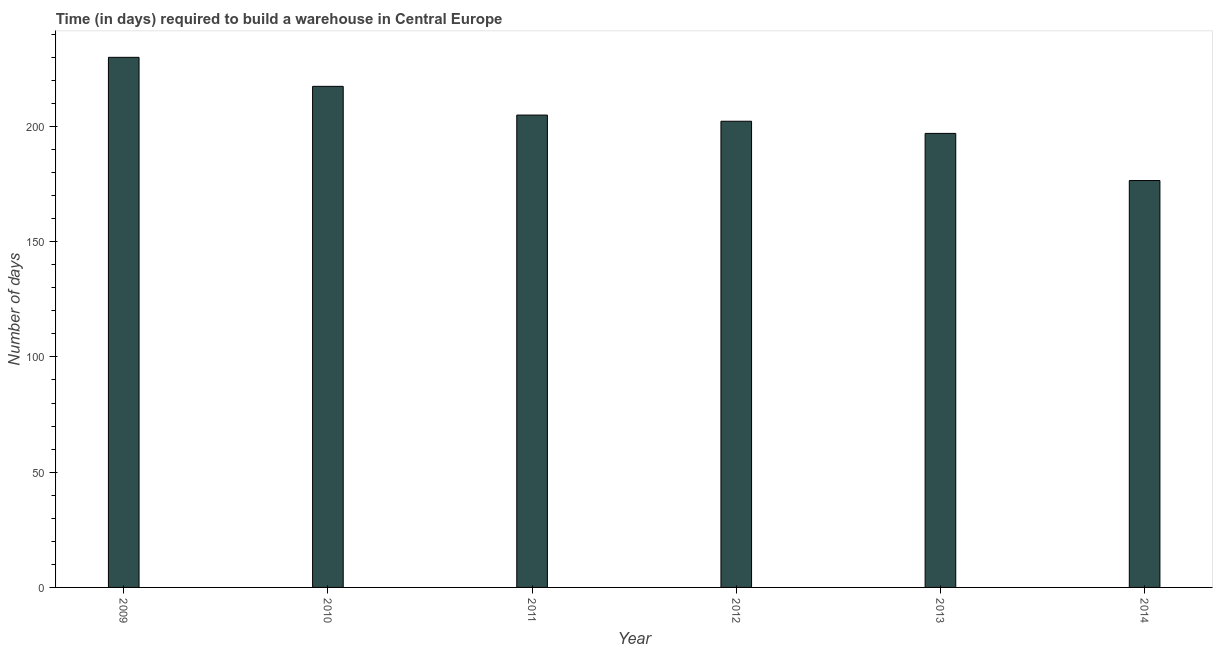Does the graph contain any zero values?
Offer a terse response. No. What is the title of the graph?
Give a very brief answer. Time (in days) required to build a warehouse in Central Europe. What is the label or title of the X-axis?
Your response must be concise. Year. What is the label or title of the Y-axis?
Provide a short and direct response. Number of days. What is the time required to build a warehouse in 2009?
Make the answer very short. 229.95. Across all years, what is the maximum time required to build a warehouse?
Keep it short and to the point. 229.95. Across all years, what is the minimum time required to build a warehouse?
Make the answer very short. 176.5. In which year was the time required to build a warehouse minimum?
Offer a very short reply. 2014. What is the sum of the time required to build a warehouse?
Ensure brevity in your answer.  1227.91. What is the difference between the time required to build a warehouse in 2010 and 2014?
Your answer should be compact. 40.86. What is the average time required to build a warehouse per year?
Your answer should be compact. 204.65. What is the median time required to build a warehouse?
Offer a terse response. 203.57. In how many years, is the time required to build a warehouse greater than 110 days?
Keep it short and to the point. 6. Do a majority of the years between 2011 and 2013 (inclusive) have time required to build a warehouse greater than 220 days?
Keep it short and to the point. No. What is the ratio of the time required to build a warehouse in 2011 to that in 2012?
Ensure brevity in your answer.  1.01. Is the time required to build a warehouse in 2011 less than that in 2012?
Offer a very short reply. No. What is the difference between the highest and the second highest time required to build a warehouse?
Your response must be concise. 12.59. Is the sum of the time required to build a warehouse in 2009 and 2010 greater than the maximum time required to build a warehouse across all years?
Provide a succinct answer. Yes. What is the difference between the highest and the lowest time required to build a warehouse?
Offer a very short reply. 53.45. How many years are there in the graph?
Offer a very short reply. 6. What is the Number of days in 2009?
Keep it short and to the point. 229.95. What is the Number of days of 2010?
Keep it short and to the point. 217.36. What is the Number of days in 2011?
Your response must be concise. 204.91. What is the Number of days of 2012?
Offer a very short reply. 202.23. What is the Number of days of 2013?
Offer a very short reply. 196.95. What is the Number of days in 2014?
Keep it short and to the point. 176.5. What is the difference between the Number of days in 2009 and 2010?
Offer a terse response. 12.59. What is the difference between the Number of days in 2009 and 2011?
Your answer should be very brief. 25.05. What is the difference between the Number of days in 2009 and 2012?
Your response must be concise. 27.73. What is the difference between the Number of days in 2009 and 2013?
Offer a very short reply. 33. What is the difference between the Number of days in 2009 and 2014?
Offer a terse response. 53.45. What is the difference between the Number of days in 2010 and 2011?
Ensure brevity in your answer.  12.45. What is the difference between the Number of days in 2010 and 2012?
Give a very brief answer. 15.14. What is the difference between the Number of days in 2010 and 2013?
Provide a short and direct response. 20.41. What is the difference between the Number of days in 2010 and 2014?
Your response must be concise. 40.86. What is the difference between the Number of days in 2011 and 2012?
Keep it short and to the point. 2.68. What is the difference between the Number of days in 2011 and 2013?
Ensure brevity in your answer.  7.95. What is the difference between the Number of days in 2011 and 2014?
Offer a terse response. 28.41. What is the difference between the Number of days in 2012 and 2013?
Give a very brief answer. 5.27. What is the difference between the Number of days in 2012 and 2014?
Keep it short and to the point. 25.73. What is the difference between the Number of days in 2013 and 2014?
Offer a terse response. 20.45. What is the ratio of the Number of days in 2009 to that in 2010?
Offer a very short reply. 1.06. What is the ratio of the Number of days in 2009 to that in 2011?
Your response must be concise. 1.12. What is the ratio of the Number of days in 2009 to that in 2012?
Your answer should be compact. 1.14. What is the ratio of the Number of days in 2009 to that in 2013?
Provide a succinct answer. 1.17. What is the ratio of the Number of days in 2009 to that in 2014?
Your response must be concise. 1.3. What is the ratio of the Number of days in 2010 to that in 2011?
Give a very brief answer. 1.06. What is the ratio of the Number of days in 2010 to that in 2012?
Provide a short and direct response. 1.07. What is the ratio of the Number of days in 2010 to that in 2013?
Make the answer very short. 1.1. What is the ratio of the Number of days in 2010 to that in 2014?
Give a very brief answer. 1.23. What is the ratio of the Number of days in 2011 to that in 2012?
Your answer should be very brief. 1.01. What is the ratio of the Number of days in 2011 to that in 2014?
Your answer should be compact. 1.16. What is the ratio of the Number of days in 2012 to that in 2013?
Keep it short and to the point. 1.03. What is the ratio of the Number of days in 2012 to that in 2014?
Your response must be concise. 1.15. What is the ratio of the Number of days in 2013 to that in 2014?
Offer a terse response. 1.12. 